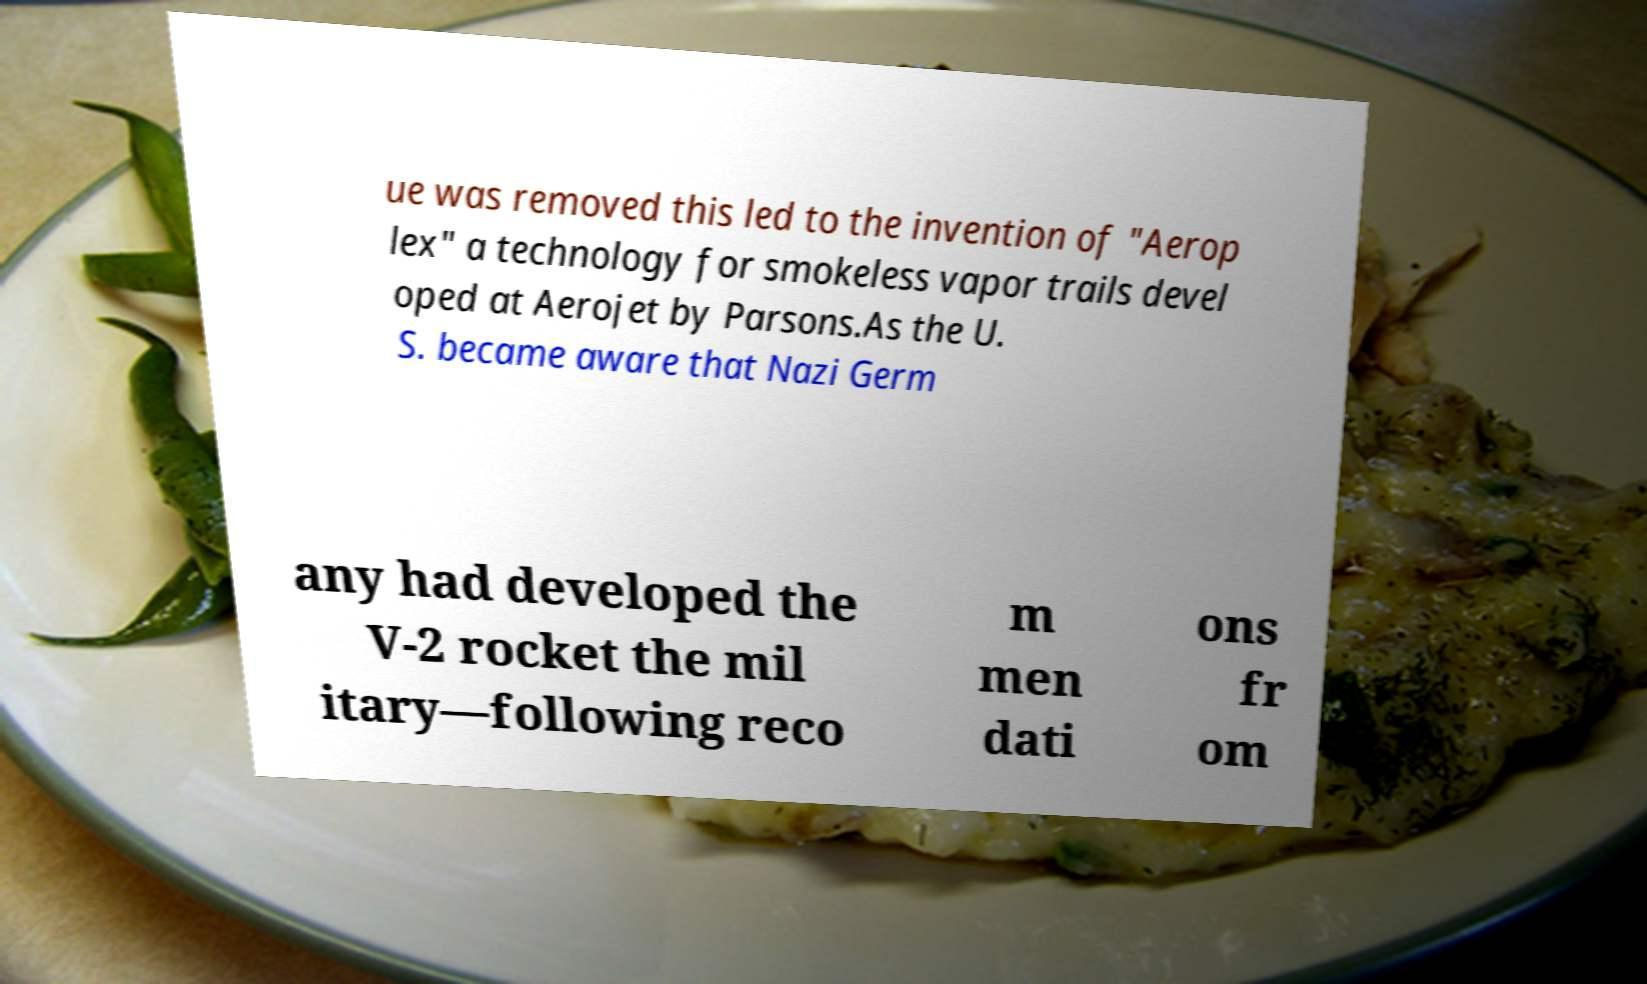There's text embedded in this image that I need extracted. Can you transcribe it verbatim? ue was removed this led to the invention of "Aerop lex" a technology for smokeless vapor trails devel oped at Aerojet by Parsons.As the U. S. became aware that Nazi Germ any had developed the V-2 rocket the mil itary—following reco m men dati ons fr om 